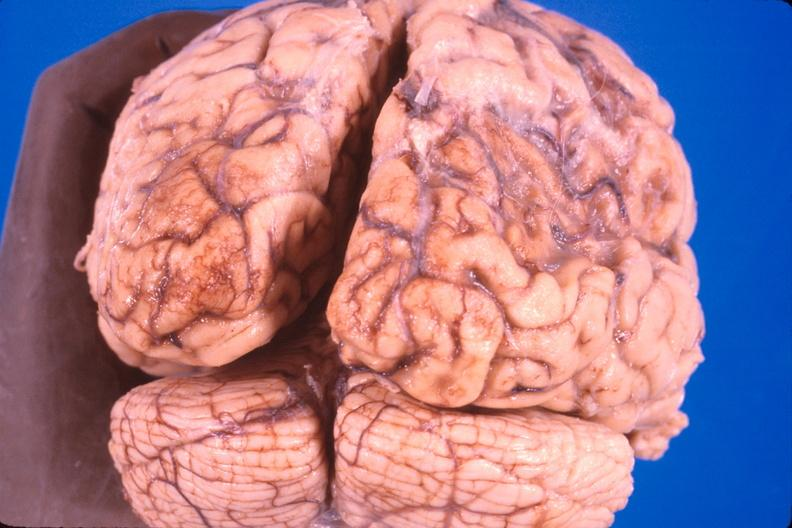s metastatic neuroblastoma present?
Answer the question using a single word or phrase. No 